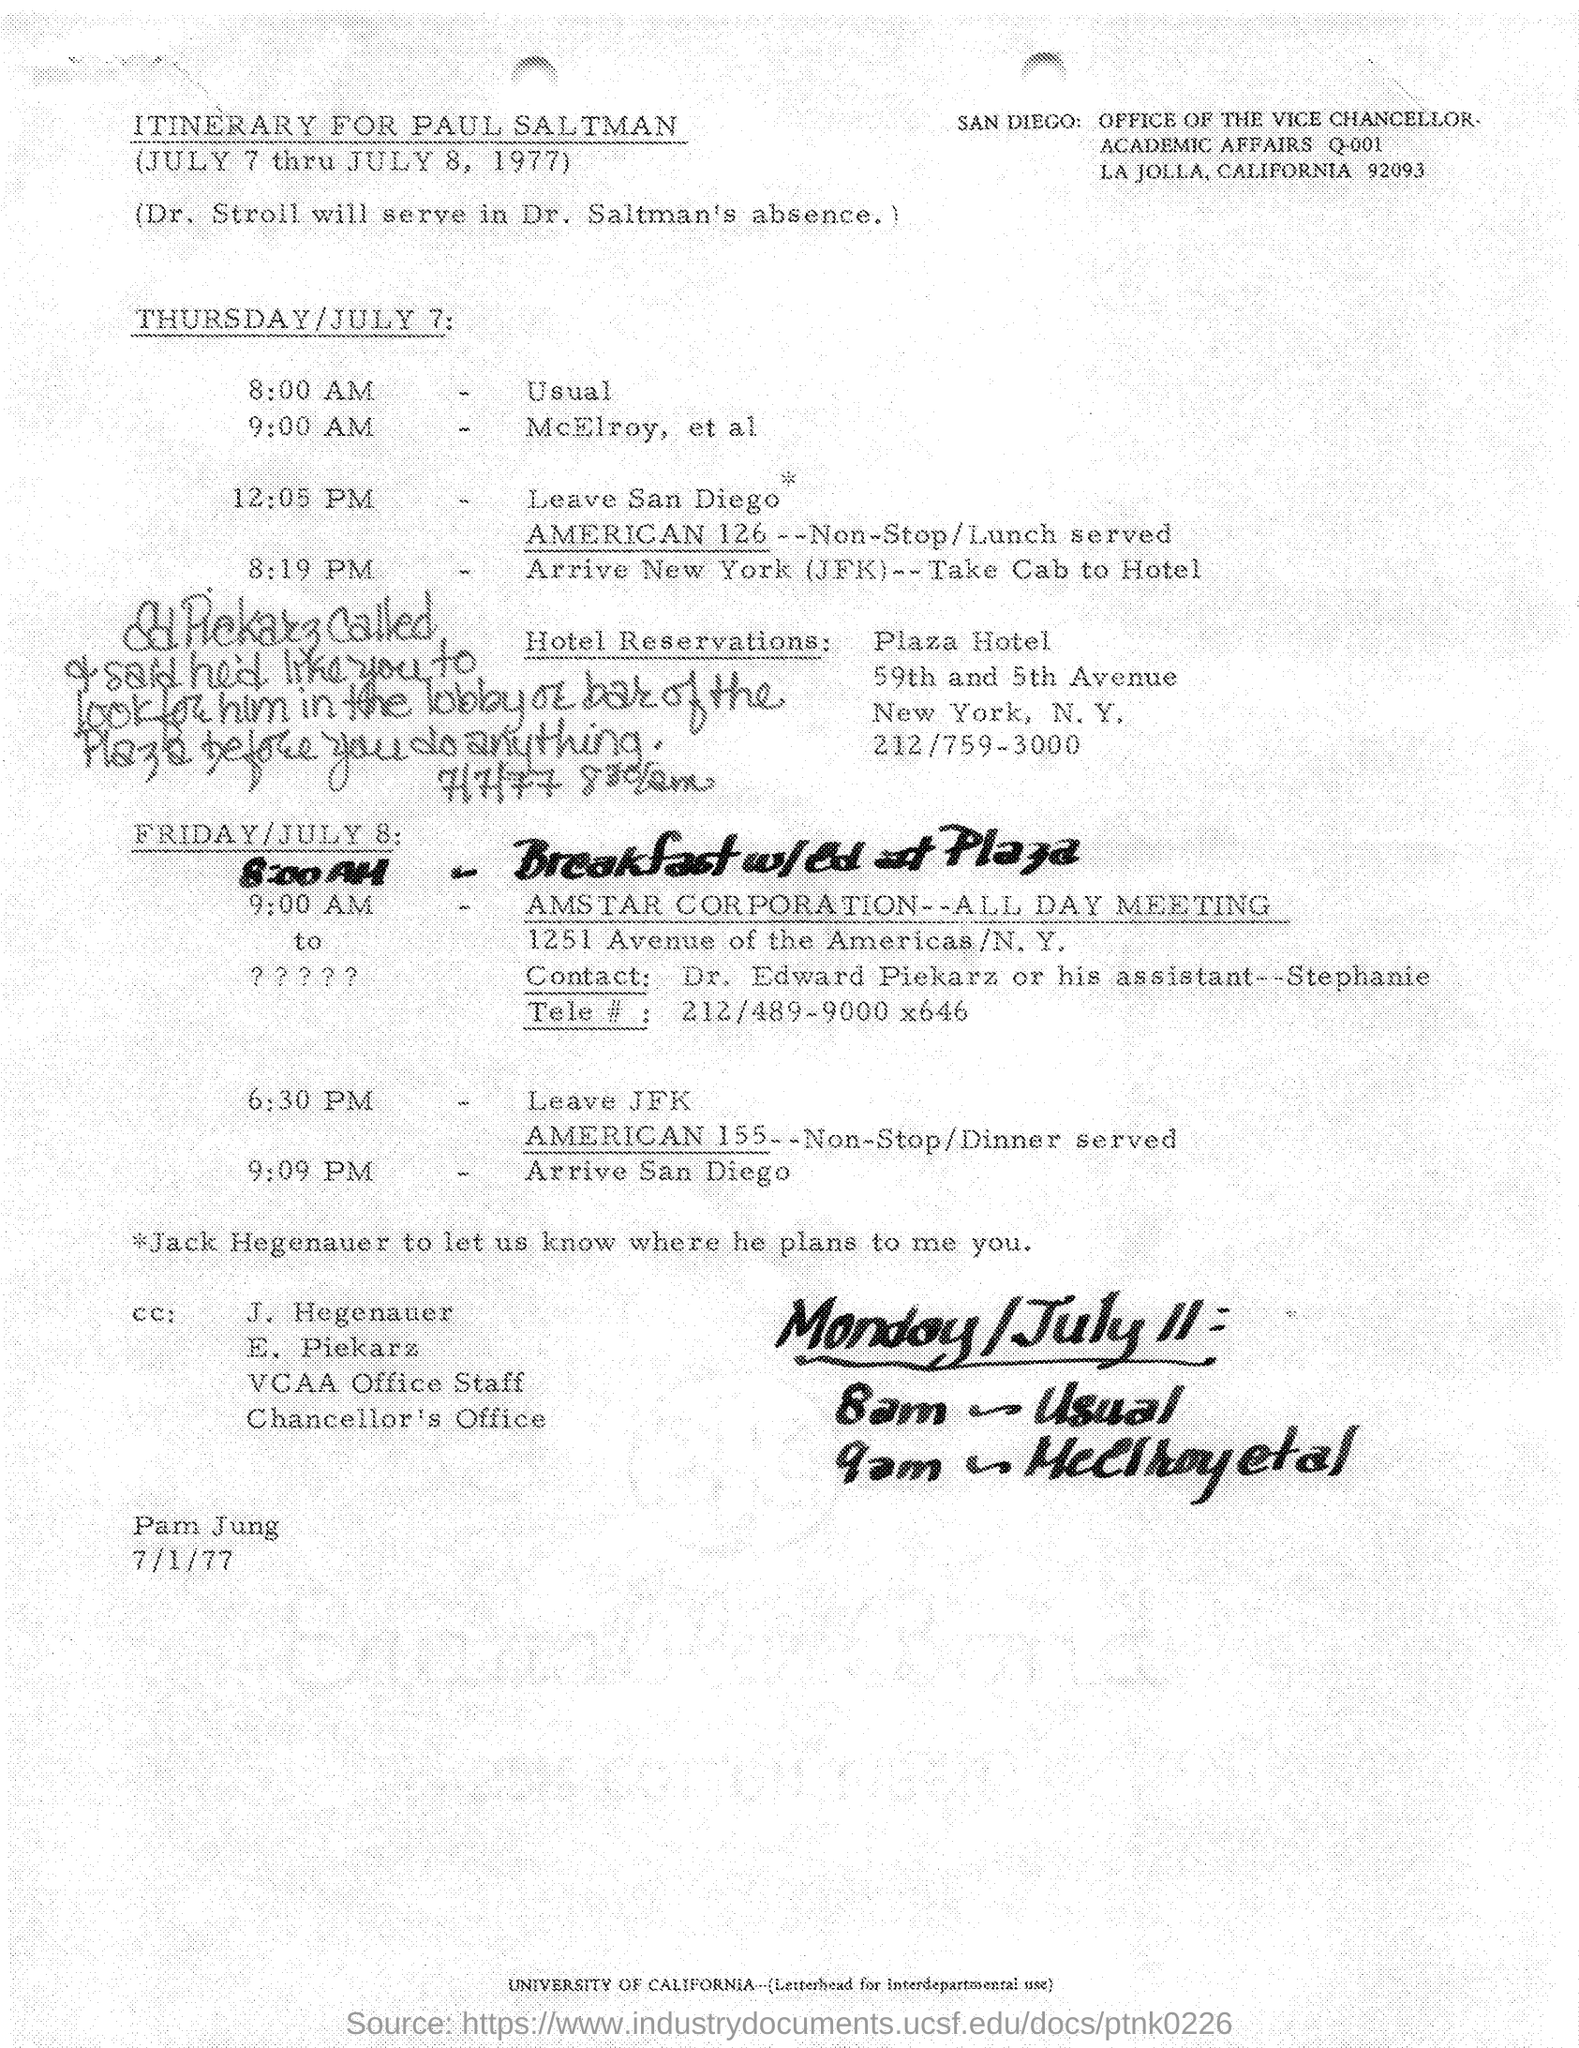Point out several critical features in this image. The itinerary belongs to Paul Saltman. The University of California is specified in the document at the bottom. 